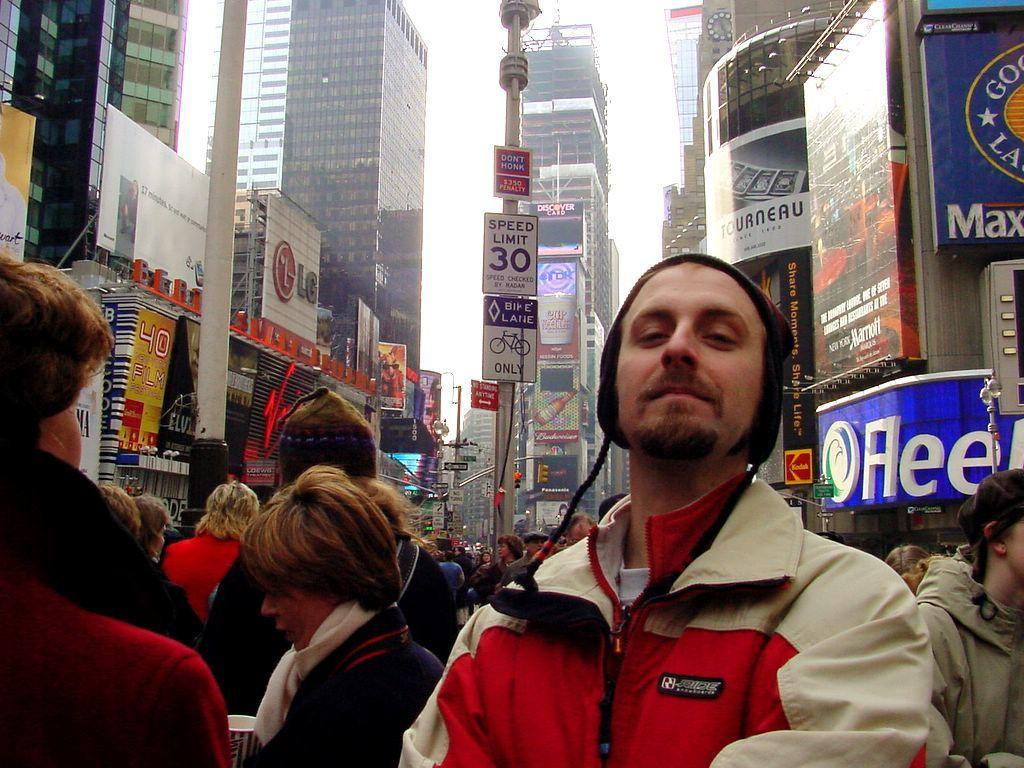<image>
Share a concise interpretation of the image provided. A crowd up people are gathered under a sign that says Speed Limit 30 in a downtown city street. 